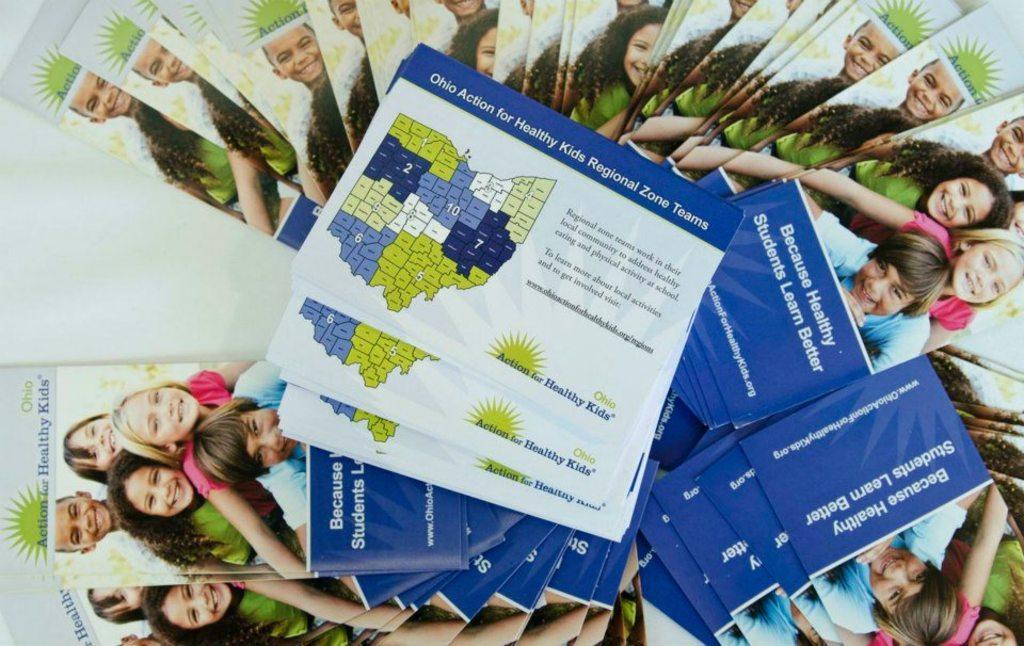How would you summarize this image in a sentence or two? In this image there are so many books and some pamphlets kept on a table. 